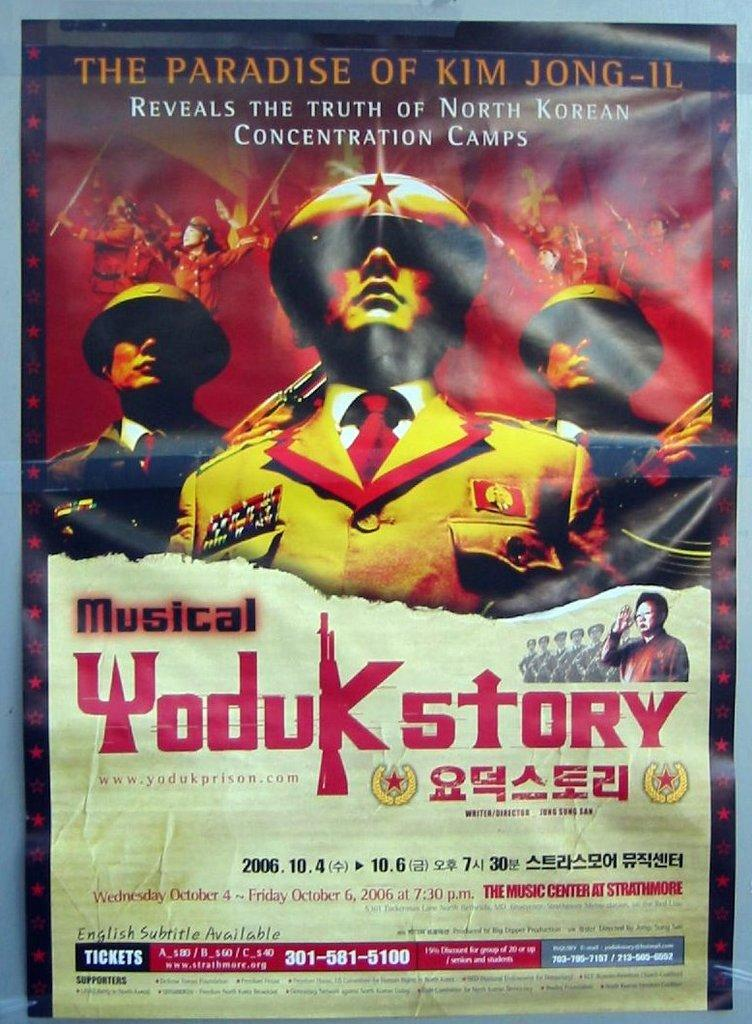<image>
Write a terse but informative summary of the picture. a poster that says 'the paradise of kim jong-il' on it 